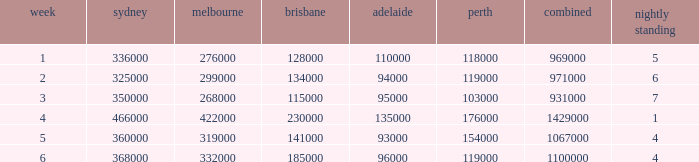What was the total rating on week 3?  931000.0. 